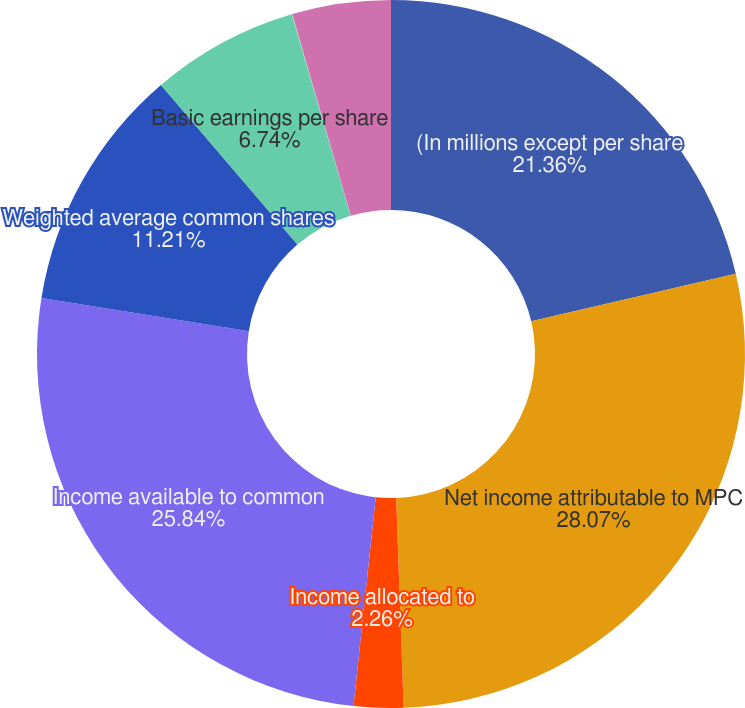Convert chart. <chart><loc_0><loc_0><loc_500><loc_500><pie_chart><fcel>(In millions except per share<fcel>Net income attributable to MPC<fcel>Income allocated to<fcel>Income available to common<fcel>Weighted average common shares<fcel>Basic earnings per share<fcel>Effect of dilutive securities<fcel>Diluted earnings per share<nl><fcel>21.36%<fcel>28.07%<fcel>2.26%<fcel>25.84%<fcel>11.21%<fcel>6.74%<fcel>0.02%<fcel>4.5%<nl></chart> 